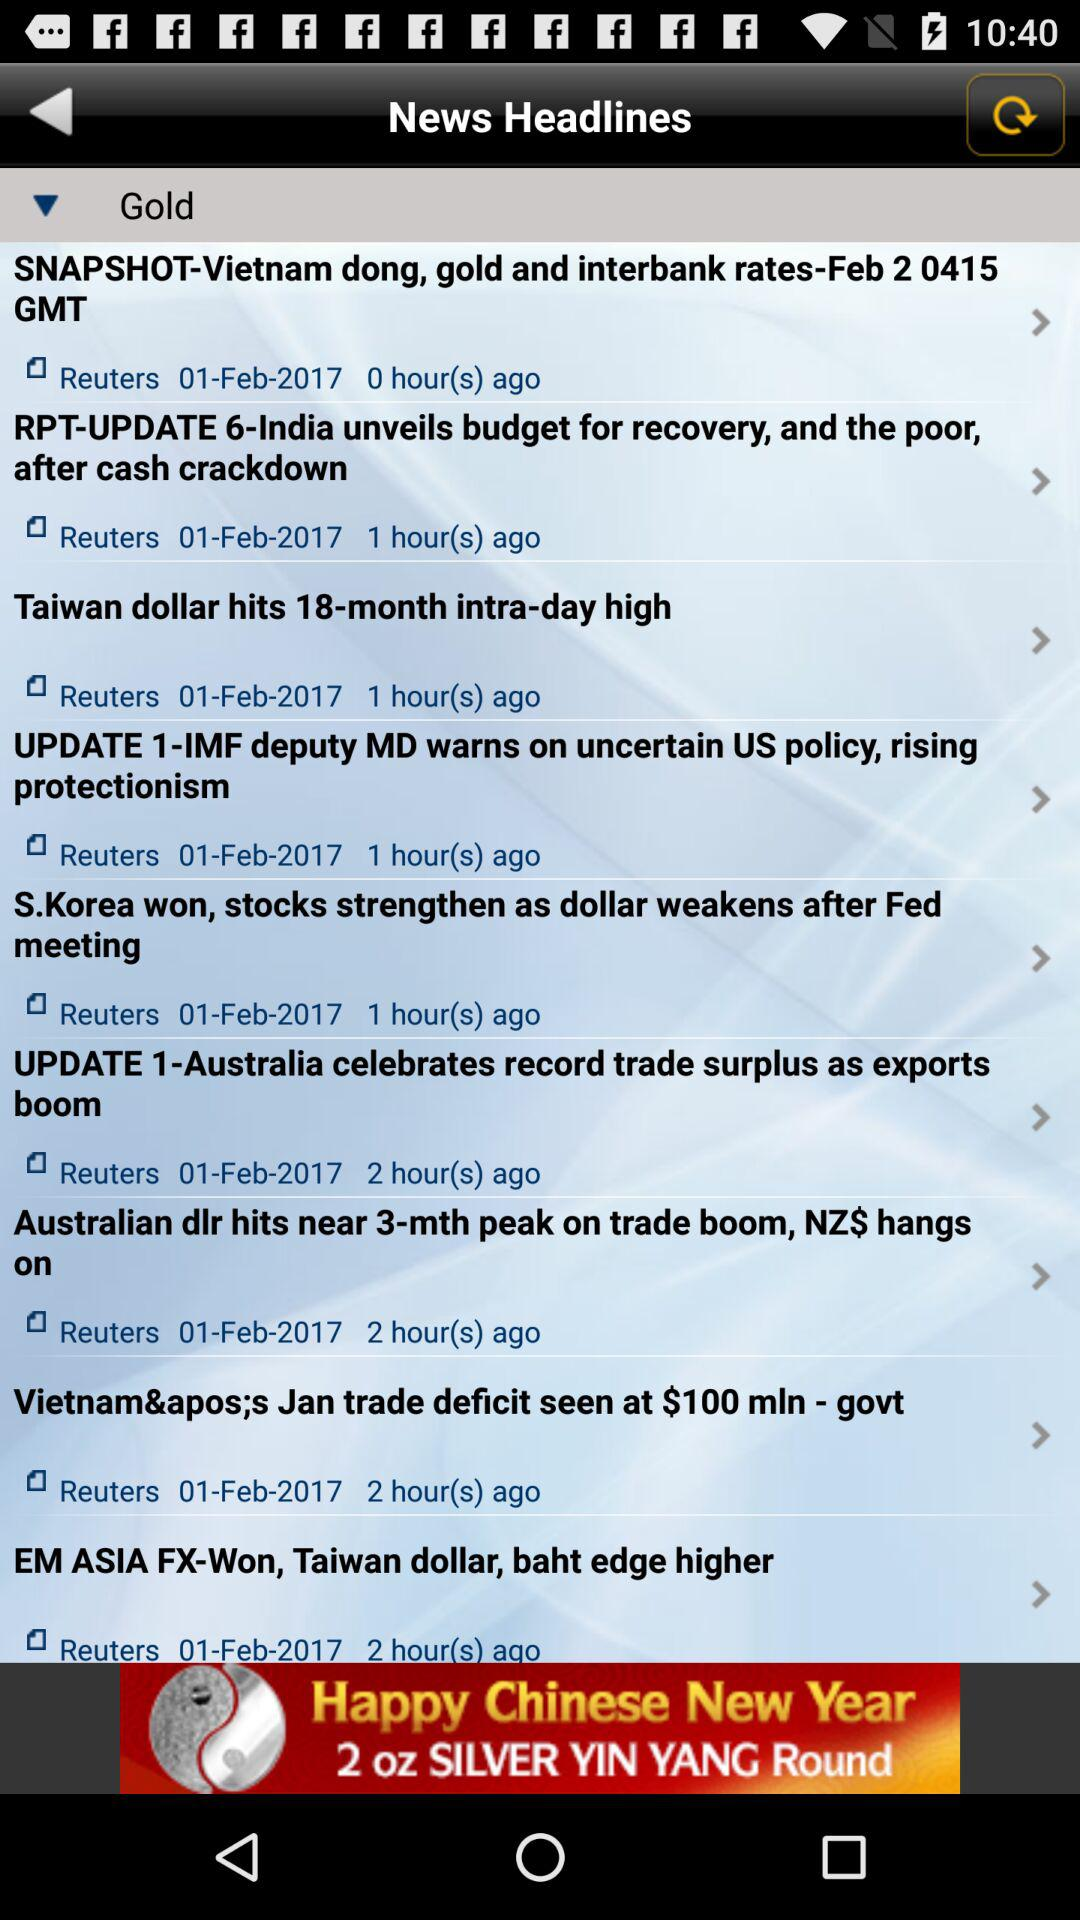Who is the author of the article "EX ASIA FX-Won, Taiwan dollar, baht edge higher"? The author of the article "EX ASIA FX-Won, Taiwan dollar, baht edge higher" is Reuters. 